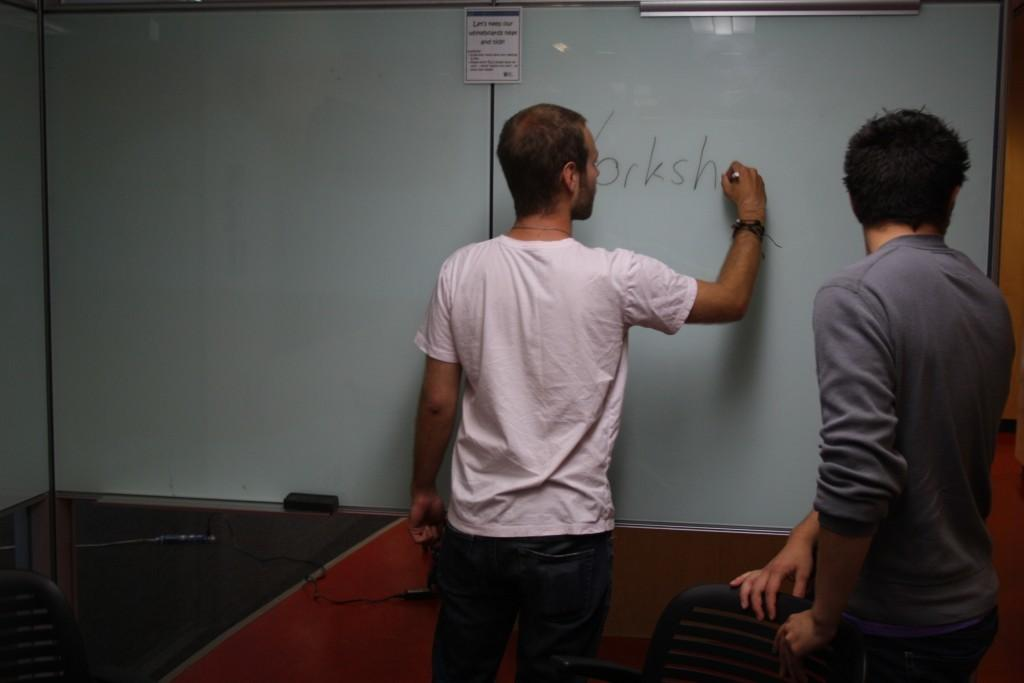Provide a one-sentence caption for the provided image. One man has written the letters Yorksh on a white board while another stands behind him. 